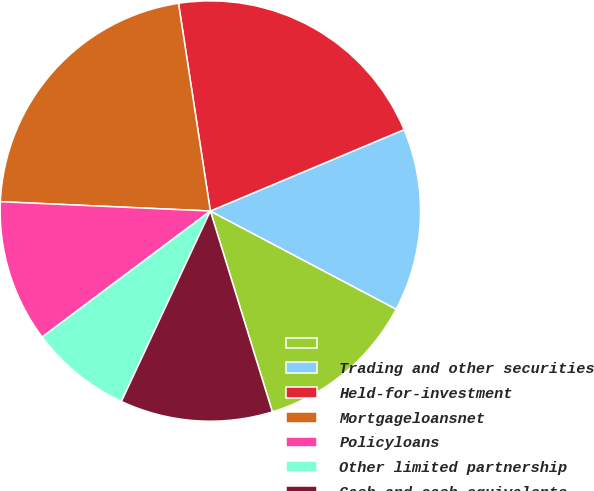Convert chart. <chart><loc_0><loc_0><loc_500><loc_500><pie_chart><ecel><fcel>Trading and other securities<fcel>Held-for-investment<fcel>Mortgageloansnet<fcel>Policyloans<fcel>Other limited partnership<fcel>Cash and cash equivalents<nl><fcel>12.5%<fcel>14.06%<fcel>21.09%<fcel>21.87%<fcel>10.94%<fcel>7.81%<fcel>11.72%<nl></chart> 